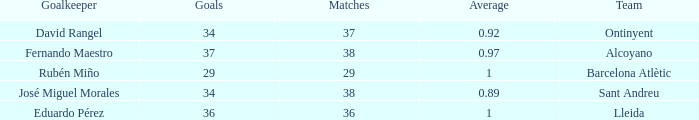Parse the full table. {'header': ['Goalkeeper', 'Goals', 'Matches', 'Average', 'Team'], 'rows': [['David Rangel', '34', '37', '0.92', 'Ontinyent'], ['Fernando Maestro', '37', '38', '0.97', 'Alcoyano'], ['Rubén Miño', '29', '29', '1', 'Barcelona Atlètic'], ['José Miguel Morales', '34', '38', '0.89', 'Sant Andreu'], ['Eduardo Pérez', '36', '36', '1', 'Lleida']]} What is the highest Average, when Goals is "34", and when Matches is less than 37? None. 